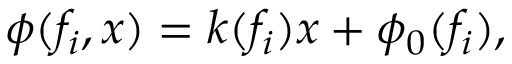Convert formula to latex. <formula><loc_0><loc_0><loc_500><loc_500>\phi ( f _ { i } , x ) = k ( f _ { i } ) x + \phi _ { 0 } ( f _ { i } ) ,</formula> 